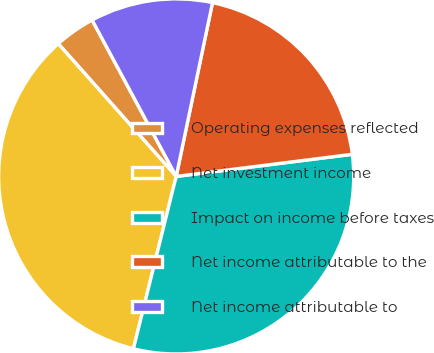Convert chart to OTSL. <chart><loc_0><loc_0><loc_500><loc_500><pie_chart><fcel>Operating expenses reflected<fcel>Net investment income<fcel>Impact on income before taxes<fcel>Net income attributable to the<fcel>Net income attributable to<nl><fcel>3.71%<fcel>34.57%<fcel>30.86%<fcel>19.73%<fcel>11.13%<nl></chart> 